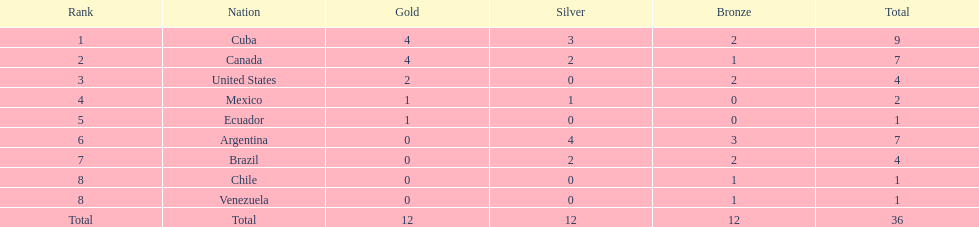Which nations participated? Cuba, Canada, United States, Mexico, Ecuador, Argentina, Brazil, Chile, Venezuela. Which nations won gold? Cuba, Canada, United States, Mexico, Ecuador. Which nations did not win silver? United States, Ecuador, Chile, Venezuela. Out of those countries previously listed, which nation won gold? United States. 